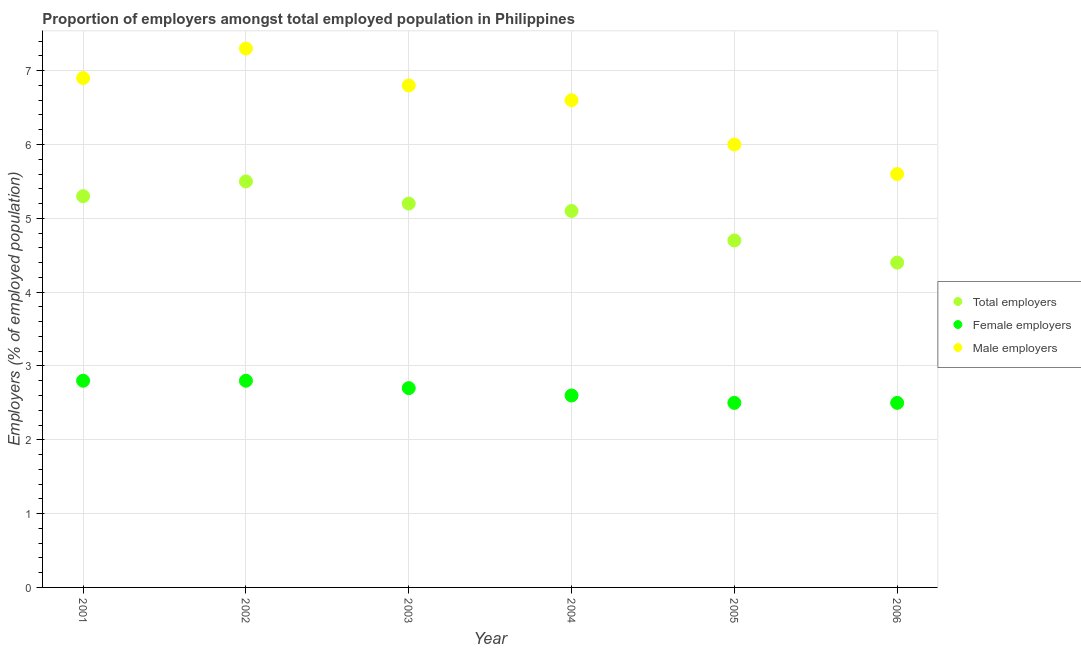How many different coloured dotlines are there?
Provide a short and direct response. 3. What is the percentage of female employers in 2003?
Your response must be concise. 2.7. Across all years, what is the maximum percentage of male employers?
Your response must be concise. 7.3. Across all years, what is the minimum percentage of male employers?
Keep it short and to the point. 5.6. In which year was the percentage of male employers minimum?
Offer a very short reply. 2006. What is the total percentage of male employers in the graph?
Give a very brief answer. 39.2. What is the difference between the percentage of female employers in 2004 and that in 2006?
Offer a terse response. 0.1. What is the difference between the percentage of male employers in 2001 and the percentage of female employers in 2004?
Your answer should be compact. 4.3. What is the average percentage of male employers per year?
Your answer should be compact. 6.53. In the year 2001, what is the difference between the percentage of total employers and percentage of female employers?
Keep it short and to the point. 2.5. In how many years, is the percentage of male employers greater than 4.4 %?
Provide a short and direct response. 6. Is the percentage of female employers in 2001 less than that in 2006?
Offer a very short reply. No. Is the difference between the percentage of male employers in 2004 and 2005 greater than the difference between the percentage of total employers in 2004 and 2005?
Ensure brevity in your answer.  Yes. What is the difference between the highest and the second highest percentage of female employers?
Ensure brevity in your answer.  0. What is the difference between the highest and the lowest percentage of male employers?
Ensure brevity in your answer.  1.7. Is the sum of the percentage of female employers in 2002 and 2006 greater than the maximum percentage of male employers across all years?
Keep it short and to the point. No. Is it the case that in every year, the sum of the percentage of total employers and percentage of female employers is greater than the percentage of male employers?
Ensure brevity in your answer.  Yes. Does the percentage of male employers monotonically increase over the years?
Offer a very short reply. No. How many dotlines are there?
Give a very brief answer. 3. Are the values on the major ticks of Y-axis written in scientific E-notation?
Offer a terse response. No. Does the graph contain any zero values?
Your answer should be compact. No. Does the graph contain grids?
Provide a succinct answer. Yes. How many legend labels are there?
Offer a very short reply. 3. How are the legend labels stacked?
Provide a succinct answer. Vertical. What is the title of the graph?
Offer a terse response. Proportion of employers amongst total employed population in Philippines. Does "Financial account" appear as one of the legend labels in the graph?
Your answer should be compact. No. What is the label or title of the Y-axis?
Keep it short and to the point. Employers (% of employed population). What is the Employers (% of employed population) in Total employers in 2001?
Provide a short and direct response. 5.3. What is the Employers (% of employed population) of Female employers in 2001?
Make the answer very short. 2.8. What is the Employers (% of employed population) of Male employers in 2001?
Keep it short and to the point. 6.9. What is the Employers (% of employed population) of Total employers in 2002?
Give a very brief answer. 5.5. What is the Employers (% of employed population) of Female employers in 2002?
Keep it short and to the point. 2.8. What is the Employers (% of employed population) of Male employers in 2002?
Provide a succinct answer. 7.3. What is the Employers (% of employed population) in Total employers in 2003?
Your answer should be compact. 5.2. What is the Employers (% of employed population) in Female employers in 2003?
Your response must be concise. 2.7. What is the Employers (% of employed population) of Male employers in 2003?
Keep it short and to the point. 6.8. What is the Employers (% of employed population) in Total employers in 2004?
Your response must be concise. 5.1. What is the Employers (% of employed population) in Female employers in 2004?
Provide a short and direct response. 2.6. What is the Employers (% of employed population) in Male employers in 2004?
Provide a succinct answer. 6.6. What is the Employers (% of employed population) in Total employers in 2005?
Your response must be concise. 4.7. What is the Employers (% of employed population) in Male employers in 2005?
Your answer should be compact. 6. What is the Employers (% of employed population) in Total employers in 2006?
Your response must be concise. 4.4. What is the Employers (% of employed population) in Male employers in 2006?
Ensure brevity in your answer.  5.6. Across all years, what is the maximum Employers (% of employed population) in Female employers?
Provide a succinct answer. 2.8. Across all years, what is the maximum Employers (% of employed population) of Male employers?
Give a very brief answer. 7.3. Across all years, what is the minimum Employers (% of employed population) in Total employers?
Make the answer very short. 4.4. Across all years, what is the minimum Employers (% of employed population) of Male employers?
Your response must be concise. 5.6. What is the total Employers (% of employed population) in Total employers in the graph?
Provide a succinct answer. 30.2. What is the total Employers (% of employed population) in Male employers in the graph?
Offer a very short reply. 39.2. What is the difference between the Employers (% of employed population) of Total employers in 2001 and that in 2002?
Make the answer very short. -0.2. What is the difference between the Employers (% of employed population) in Male employers in 2001 and that in 2002?
Keep it short and to the point. -0.4. What is the difference between the Employers (% of employed population) of Female employers in 2001 and that in 2003?
Your answer should be very brief. 0.1. What is the difference between the Employers (% of employed population) of Male employers in 2001 and that in 2003?
Your answer should be very brief. 0.1. What is the difference between the Employers (% of employed population) of Total employers in 2001 and that in 2004?
Make the answer very short. 0.2. What is the difference between the Employers (% of employed population) of Female employers in 2001 and that in 2004?
Provide a succinct answer. 0.2. What is the difference between the Employers (% of employed population) in Total employers in 2001 and that in 2005?
Your response must be concise. 0.6. What is the difference between the Employers (% of employed population) of Female employers in 2001 and that in 2005?
Offer a very short reply. 0.3. What is the difference between the Employers (% of employed population) in Male employers in 2001 and that in 2005?
Give a very brief answer. 0.9. What is the difference between the Employers (% of employed population) in Total employers in 2001 and that in 2006?
Your answer should be compact. 0.9. What is the difference between the Employers (% of employed population) of Female employers in 2001 and that in 2006?
Provide a short and direct response. 0.3. What is the difference between the Employers (% of employed population) in Male employers in 2001 and that in 2006?
Offer a very short reply. 1.3. What is the difference between the Employers (% of employed population) in Total employers in 2002 and that in 2003?
Your answer should be compact. 0.3. What is the difference between the Employers (% of employed population) in Female employers in 2002 and that in 2004?
Keep it short and to the point. 0.2. What is the difference between the Employers (% of employed population) of Male employers in 2002 and that in 2004?
Offer a terse response. 0.7. What is the difference between the Employers (% of employed population) of Total employers in 2002 and that in 2005?
Your answer should be very brief. 0.8. What is the difference between the Employers (% of employed population) in Female employers in 2002 and that in 2005?
Your answer should be compact. 0.3. What is the difference between the Employers (% of employed population) of Female employers in 2002 and that in 2006?
Ensure brevity in your answer.  0.3. What is the difference between the Employers (% of employed population) of Female employers in 2003 and that in 2004?
Provide a short and direct response. 0.1. What is the difference between the Employers (% of employed population) in Male employers in 2003 and that in 2004?
Provide a short and direct response. 0.2. What is the difference between the Employers (% of employed population) in Male employers in 2003 and that in 2005?
Provide a succinct answer. 0.8. What is the difference between the Employers (% of employed population) of Total employers in 2003 and that in 2006?
Your answer should be very brief. 0.8. What is the difference between the Employers (% of employed population) in Total employers in 2004 and that in 2005?
Provide a succinct answer. 0.4. What is the difference between the Employers (% of employed population) in Female employers in 2004 and that in 2005?
Provide a short and direct response. 0.1. What is the difference between the Employers (% of employed population) in Male employers in 2004 and that in 2005?
Provide a short and direct response. 0.6. What is the difference between the Employers (% of employed population) of Female employers in 2004 and that in 2006?
Your response must be concise. 0.1. What is the difference between the Employers (% of employed population) in Female employers in 2005 and that in 2006?
Offer a very short reply. 0. What is the difference between the Employers (% of employed population) of Total employers in 2001 and the Employers (% of employed population) of Male employers in 2002?
Your response must be concise. -2. What is the difference between the Employers (% of employed population) of Total employers in 2001 and the Employers (% of employed population) of Male employers in 2003?
Keep it short and to the point. -1.5. What is the difference between the Employers (% of employed population) of Total employers in 2001 and the Employers (% of employed population) of Female employers in 2005?
Offer a terse response. 2.8. What is the difference between the Employers (% of employed population) in Total employers in 2001 and the Employers (% of employed population) in Male employers in 2006?
Your answer should be very brief. -0.3. What is the difference between the Employers (% of employed population) in Total employers in 2002 and the Employers (% of employed population) in Female employers in 2003?
Your answer should be very brief. 2.8. What is the difference between the Employers (% of employed population) in Total employers in 2002 and the Employers (% of employed population) in Male employers in 2003?
Offer a very short reply. -1.3. What is the difference between the Employers (% of employed population) of Total employers in 2002 and the Employers (% of employed population) of Female employers in 2004?
Offer a very short reply. 2.9. What is the difference between the Employers (% of employed population) in Total employers in 2002 and the Employers (% of employed population) in Male employers in 2004?
Ensure brevity in your answer.  -1.1. What is the difference between the Employers (% of employed population) of Total employers in 2002 and the Employers (% of employed population) of Male employers in 2005?
Give a very brief answer. -0.5. What is the difference between the Employers (% of employed population) in Female employers in 2002 and the Employers (% of employed population) in Male employers in 2005?
Provide a succinct answer. -3.2. What is the difference between the Employers (% of employed population) in Total employers in 2002 and the Employers (% of employed population) in Male employers in 2006?
Keep it short and to the point. -0.1. What is the difference between the Employers (% of employed population) of Female employers in 2002 and the Employers (% of employed population) of Male employers in 2006?
Offer a very short reply. -2.8. What is the difference between the Employers (% of employed population) of Total employers in 2003 and the Employers (% of employed population) of Female employers in 2004?
Offer a terse response. 2.6. What is the difference between the Employers (% of employed population) in Female employers in 2003 and the Employers (% of employed population) in Male employers in 2004?
Ensure brevity in your answer.  -3.9. What is the difference between the Employers (% of employed population) of Total employers in 2003 and the Employers (% of employed population) of Female employers in 2005?
Your answer should be compact. 2.7. What is the difference between the Employers (% of employed population) in Total employers in 2003 and the Employers (% of employed population) in Male employers in 2005?
Offer a very short reply. -0.8. What is the difference between the Employers (% of employed population) in Female employers in 2003 and the Employers (% of employed population) in Male employers in 2005?
Keep it short and to the point. -3.3. What is the difference between the Employers (% of employed population) of Female employers in 2003 and the Employers (% of employed population) of Male employers in 2006?
Give a very brief answer. -2.9. What is the difference between the Employers (% of employed population) in Total employers in 2004 and the Employers (% of employed population) in Male employers in 2005?
Your response must be concise. -0.9. What is the difference between the Employers (% of employed population) in Female employers in 2004 and the Employers (% of employed population) in Male employers in 2005?
Your answer should be compact. -3.4. What is the difference between the Employers (% of employed population) in Total employers in 2004 and the Employers (% of employed population) in Male employers in 2006?
Your answer should be very brief. -0.5. What is the difference between the Employers (% of employed population) in Female employers in 2004 and the Employers (% of employed population) in Male employers in 2006?
Your answer should be compact. -3. What is the difference between the Employers (% of employed population) of Total employers in 2005 and the Employers (% of employed population) of Female employers in 2006?
Provide a succinct answer. 2.2. What is the difference between the Employers (% of employed population) of Total employers in 2005 and the Employers (% of employed population) of Male employers in 2006?
Your answer should be compact. -0.9. What is the average Employers (% of employed population) of Total employers per year?
Offer a terse response. 5.03. What is the average Employers (% of employed population) of Female employers per year?
Provide a succinct answer. 2.65. What is the average Employers (% of employed population) in Male employers per year?
Your response must be concise. 6.53. In the year 2001, what is the difference between the Employers (% of employed population) in Female employers and Employers (% of employed population) in Male employers?
Keep it short and to the point. -4.1. In the year 2002, what is the difference between the Employers (% of employed population) in Total employers and Employers (% of employed population) in Female employers?
Offer a terse response. 2.7. In the year 2002, what is the difference between the Employers (% of employed population) in Total employers and Employers (% of employed population) in Male employers?
Give a very brief answer. -1.8. In the year 2002, what is the difference between the Employers (% of employed population) in Female employers and Employers (% of employed population) in Male employers?
Offer a very short reply. -4.5. In the year 2003, what is the difference between the Employers (% of employed population) of Total employers and Employers (% of employed population) of Female employers?
Provide a short and direct response. 2.5. In the year 2004, what is the difference between the Employers (% of employed population) of Total employers and Employers (% of employed population) of Female employers?
Provide a succinct answer. 2.5. In the year 2004, what is the difference between the Employers (% of employed population) in Female employers and Employers (% of employed population) in Male employers?
Offer a very short reply. -4. In the year 2005, what is the difference between the Employers (% of employed population) in Total employers and Employers (% of employed population) in Female employers?
Your answer should be compact. 2.2. In the year 2005, what is the difference between the Employers (% of employed population) in Female employers and Employers (% of employed population) in Male employers?
Your response must be concise. -3.5. In the year 2006, what is the difference between the Employers (% of employed population) of Total employers and Employers (% of employed population) of Female employers?
Provide a succinct answer. 1.9. In the year 2006, what is the difference between the Employers (% of employed population) of Total employers and Employers (% of employed population) of Male employers?
Keep it short and to the point. -1.2. What is the ratio of the Employers (% of employed population) of Total employers in 2001 to that in 2002?
Ensure brevity in your answer.  0.96. What is the ratio of the Employers (% of employed population) of Male employers in 2001 to that in 2002?
Offer a terse response. 0.95. What is the ratio of the Employers (% of employed population) of Total employers in 2001 to that in 2003?
Your answer should be compact. 1.02. What is the ratio of the Employers (% of employed population) of Female employers in 2001 to that in 2003?
Provide a short and direct response. 1.04. What is the ratio of the Employers (% of employed population) in Male employers in 2001 to that in 2003?
Make the answer very short. 1.01. What is the ratio of the Employers (% of employed population) in Total employers in 2001 to that in 2004?
Your answer should be very brief. 1.04. What is the ratio of the Employers (% of employed population) in Female employers in 2001 to that in 2004?
Keep it short and to the point. 1.08. What is the ratio of the Employers (% of employed population) of Male employers in 2001 to that in 2004?
Offer a terse response. 1.05. What is the ratio of the Employers (% of employed population) of Total employers in 2001 to that in 2005?
Your answer should be very brief. 1.13. What is the ratio of the Employers (% of employed population) of Female employers in 2001 to that in 2005?
Your response must be concise. 1.12. What is the ratio of the Employers (% of employed population) of Male employers in 2001 to that in 2005?
Give a very brief answer. 1.15. What is the ratio of the Employers (% of employed population) of Total employers in 2001 to that in 2006?
Provide a short and direct response. 1.2. What is the ratio of the Employers (% of employed population) in Female employers in 2001 to that in 2006?
Offer a terse response. 1.12. What is the ratio of the Employers (% of employed population) in Male employers in 2001 to that in 2006?
Ensure brevity in your answer.  1.23. What is the ratio of the Employers (% of employed population) in Total employers in 2002 to that in 2003?
Make the answer very short. 1.06. What is the ratio of the Employers (% of employed population) in Male employers in 2002 to that in 2003?
Provide a short and direct response. 1.07. What is the ratio of the Employers (% of employed population) of Total employers in 2002 to that in 2004?
Ensure brevity in your answer.  1.08. What is the ratio of the Employers (% of employed population) of Female employers in 2002 to that in 2004?
Give a very brief answer. 1.08. What is the ratio of the Employers (% of employed population) in Male employers in 2002 to that in 2004?
Provide a short and direct response. 1.11. What is the ratio of the Employers (% of employed population) of Total employers in 2002 to that in 2005?
Make the answer very short. 1.17. What is the ratio of the Employers (% of employed population) of Female employers in 2002 to that in 2005?
Your response must be concise. 1.12. What is the ratio of the Employers (% of employed population) in Male employers in 2002 to that in 2005?
Keep it short and to the point. 1.22. What is the ratio of the Employers (% of employed population) of Total employers in 2002 to that in 2006?
Ensure brevity in your answer.  1.25. What is the ratio of the Employers (% of employed population) of Female employers in 2002 to that in 2006?
Your response must be concise. 1.12. What is the ratio of the Employers (% of employed population) in Male employers in 2002 to that in 2006?
Offer a terse response. 1.3. What is the ratio of the Employers (% of employed population) in Total employers in 2003 to that in 2004?
Ensure brevity in your answer.  1.02. What is the ratio of the Employers (% of employed population) of Female employers in 2003 to that in 2004?
Make the answer very short. 1.04. What is the ratio of the Employers (% of employed population) in Male employers in 2003 to that in 2004?
Give a very brief answer. 1.03. What is the ratio of the Employers (% of employed population) in Total employers in 2003 to that in 2005?
Provide a short and direct response. 1.11. What is the ratio of the Employers (% of employed population) in Female employers in 2003 to that in 2005?
Ensure brevity in your answer.  1.08. What is the ratio of the Employers (% of employed population) in Male employers in 2003 to that in 2005?
Offer a terse response. 1.13. What is the ratio of the Employers (% of employed population) of Total employers in 2003 to that in 2006?
Offer a terse response. 1.18. What is the ratio of the Employers (% of employed population) of Female employers in 2003 to that in 2006?
Keep it short and to the point. 1.08. What is the ratio of the Employers (% of employed population) of Male employers in 2003 to that in 2006?
Your answer should be compact. 1.21. What is the ratio of the Employers (% of employed population) in Total employers in 2004 to that in 2005?
Provide a short and direct response. 1.09. What is the ratio of the Employers (% of employed population) of Male employers in 2004 to that in 2005?
Give a very brief answer. 1.1. What is the ratio of the Employers (% of employed population) of Total employers in 2004 to that in 2006?
Your answer should be compact. 1.16. What is the ratio of the Employers (% of employed population) of Male employers in 2004 to that in 2006?
Ensure brevity in your answer.  1.18. What is the ratio of the Employers (% of employed population) in Total employers in 2005 to that in 2006?
Offer a terse response. 1.07. What is the ratio of the Employers (% of employed population) of Female employers in 2005 to that in 2006?
Provide a succinct answer. 1. What is the ratio of the Employers (% of employed population) in Male employers in 2005 to that in 2006?
Provide a short and direct response. 1.07. What is the difference between the highest and the second highest Employers (% of employed population) of Female employers?
Ensure brevity in your answer.  0. What is the difference between the highest and the lowest Employers (% of employed population) in Total employers?
Offer a very short reply. 1.1. What is the difference between the highest and the lowest Employers (% of employed population) in Female employers?
Your response must be concise. 0.3. What is the difference between the highest and the lowest Employers (% of employed population) in Male employers?
Provide a succinct answer. 1.7. 